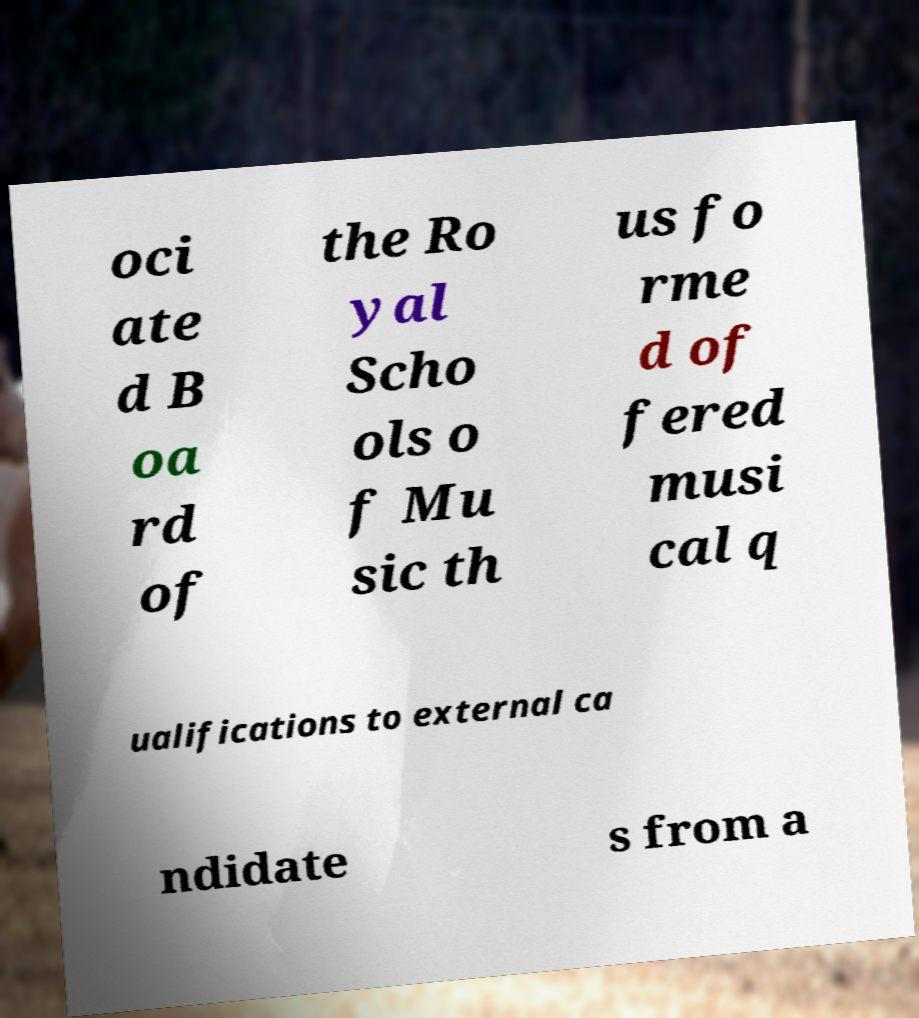Please read and relay the text visible in this image. What does it say? oci ate d B oa rd of the Ro yal Scho ols o f Mu sic th us fo rme d of fered musi cal q ualifications to external ca ndidate s from a 